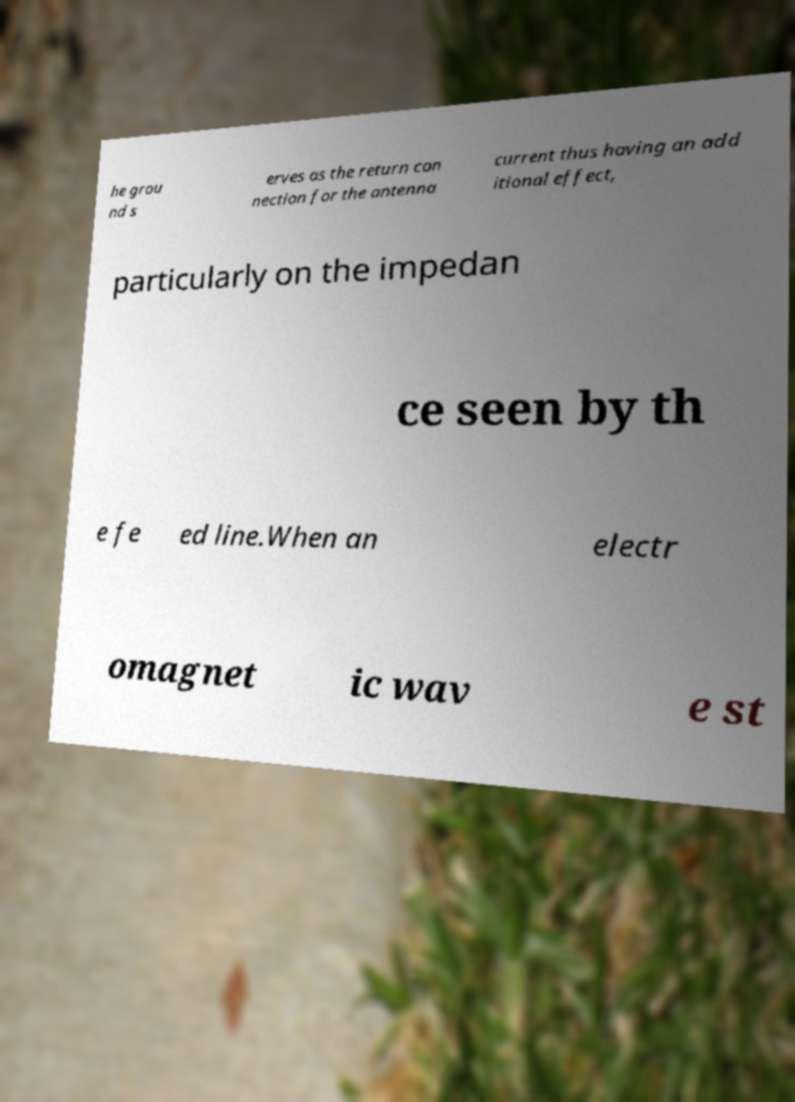Please read and relay the text visible in this image. What does it say? he grou nd s erves as the return con nection for the antenna current thus having an add itional effect, particularly on the impedan ce seen by th e fe ed line.When an electr omagnet ic wav e st 